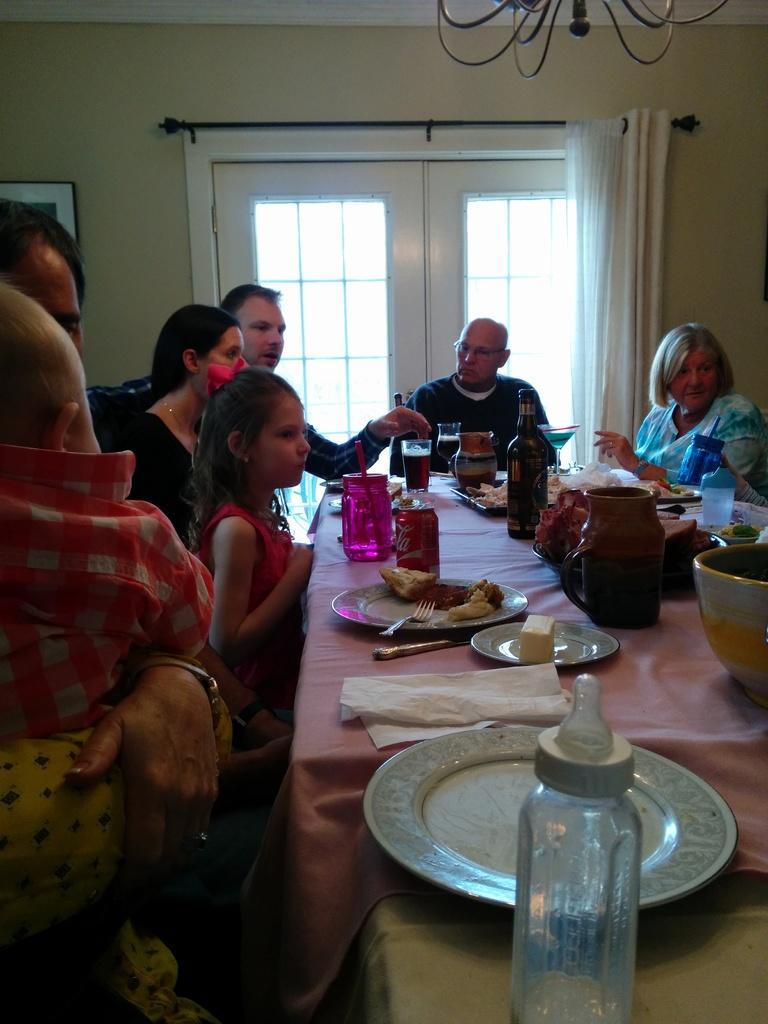Can you describe this image briefly? In the image we can see there are people who are sitting on chair and on table there is milk bottle, plate, napkin and in plates there are food items. There is jug, wine bottle, water bottle, juice glass and cold drink can. At the back there is curtain in white colour. 